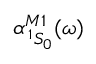Convert formula to latex. <formula><loc_0><loc_0><loc_500><loc_500>\alpha _ { \, ^ { 1 } S _ { 0 } } ^ { M 1 } ( \omega )</formula> 